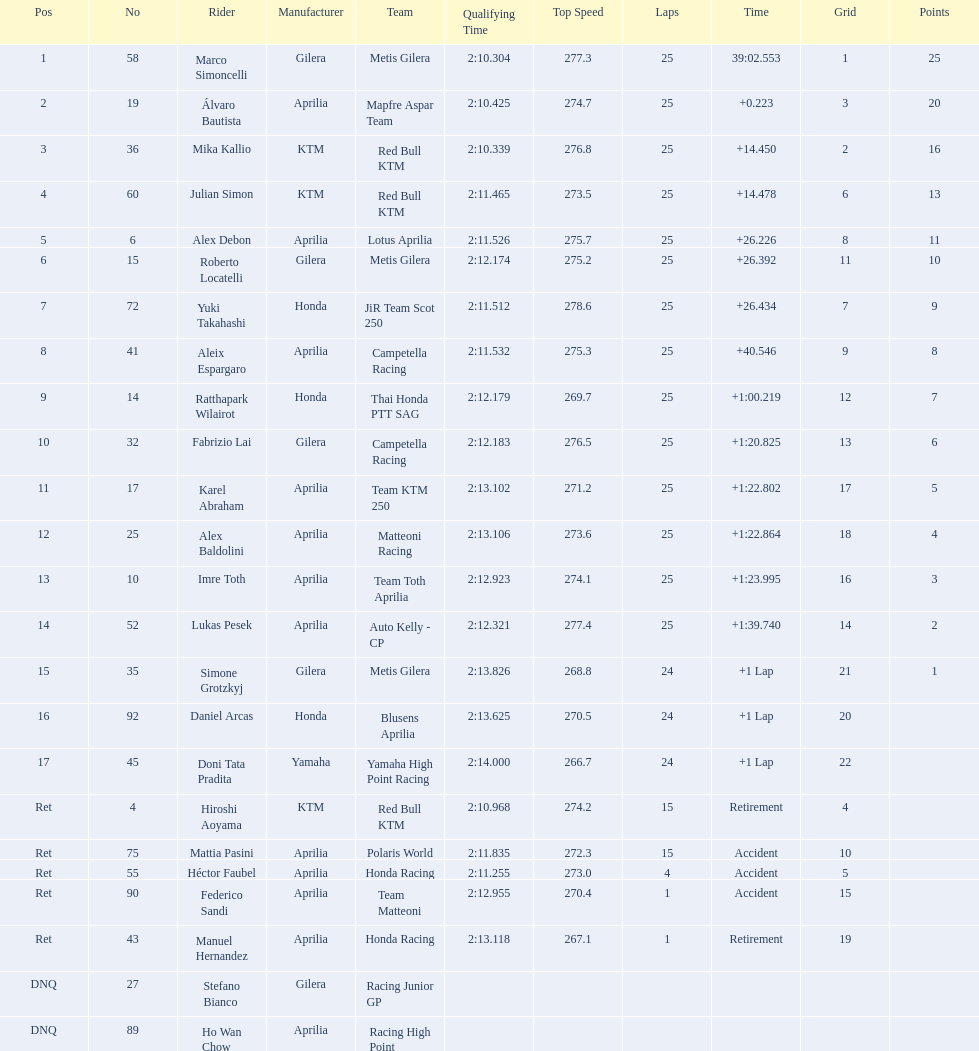What is the total number of laps performed by rider imre toth? 25. Could you help me parse every detail presented in this table? {'header': ['Pos', 'No', 'Rider', 'Manufacturer', 'Team', 'Qualifying Time', 'Top Speed', 'Laps', 'Time', 'Grid', 'Points'], 'rows': [['1', '58', 'Marco Simoncelli', 'Gilera', 'Metis Gilera', '2:10.304', '277.3', '25', '39:02.553', '1', '25'], ['2', '19', 'Álvaro Bautista', 'Aprilia', 'Mapfre Aspar Team', '2:10.425', '274.7', '25', '+0.223', '3', '20'], ['3', '36', 'Mika Kallio', 'KTM', 'Red Bull KTM', '2:10.339', '276.8', '25', '+14.450', '2', '16'], ['4', '60', 'Julian Simon', 'KTM', 'Red Bull KTM', '2:11.465', '273.5', '25', '+14.478', '6', '13'], ['5', '6', 'Alex Debon', 'Aprilia', 'Lotus Aprilia', '2:11.526', '275.7', '25', '+26.226', '8', '11'], ['6', '15', 'Roberto Locatelli', 'Gilera', 'Metis Gilera', '2:12.174', '275.2', '25', '+26.392', '11', '10'], ['7', '72', 'Yuki Takahashi', 'Honda', 'JiR Team Scot 250', '2:11.512', '278.6', '25', '+26.434', '7', '9'], ['8', '41', 'Aleix Espargaro', 'Aprilia', 'Campetella Racing', '2:11.532', '275.3', '25', '+40.546', '9', '8'], ['9', '14', 'Ratthapark Wilairot', 'Honda', 'Thai Honda PTT SAG', '2:12.179', '269.7', '25', '+1:00.219', '12', '7'], ['10', '32', 'Fabrizio Lai', 'Gilera', 'Campetella Racing', '2:12.183', '276.5', '25', '+1:20.825', '13', '6'], ['11', '17', 'Karel Abraham', 'Aprilia', 'Team KTM 250', '2:13.102', '271.2', '25', '+1:22.802', '17', '5'], ['12', '25', 'Alex Baldolini', 'Aprilia', 'Matteoni Racing', '2:13.106', '273.6', '25', '+1:22.864', '18', '4'], ['13', '10', 'Imre Toth', 'Aprilia', 'Team Toth Aprilia', '2:12.923', '274.1', '25', '+1:23.995', '16', '3'], ['14', '52', 'Lukas Pesek', 'Aprilia', 'Auto Kelly - CP', '2:12.321', '277.4', '25', '+1:39.740', '14', '2'], ['15', '35', 'Simone Grotzkyj', 'Gilera', 'Metis Gilera', '2:13.826', '268.8', '24', '+1 Lap', '21', '1'], ['16', '92', 'Daniel Arcas', 'Honda', 'Blusens Aprilia', '2:13.625', '270.5', '24', '+1 Lap', '20', ''], ['17', '45', 'Doni Tata Pradita', 'Yamaha', 'Yamaha High Point Racing', '2:14.000', '266.7', '24', '+1 Lap', '22', ''], ['Ret', '4', 'Hiroshi Aoyama', 'KTM', 'Red Bull KTM', '2:10.968', '274.2', '15', 'Retirement', '4', ''], ['Ret', '75', 'Mattia Pasini', 'Aprilia', 'Polaris World', '2:11.835', '272.3', '15', 'Accident', '10', ''], ['Ret', '55', 'Héctor Faubel', 'Aprilia', 'Honda Racing', '2:11.255', '273.0', '4', 'Accident', '5', ''], ['Ret', '90', 'Federico Sandi', 'Aprilia', 'Team Matteoni', '2:12.955', '270.4', '1', 'Accident', '15', ''], ['Ret', '43', 'Manuel Hernandez', 'Aprilia', 'Honda Racing', '2:13.118', '267.1', '1', 'Retirement', '19', ''], ['DNQ', '27', 'Stefano Bianco', 'Gilera', 'Racing Junior GP', '', '', '', '', '', ''], ['DNQ', '89', 'Ho Wan Chow', 'Aprilia', 'Racing High Point', '', '', '', '', '', '']]} 